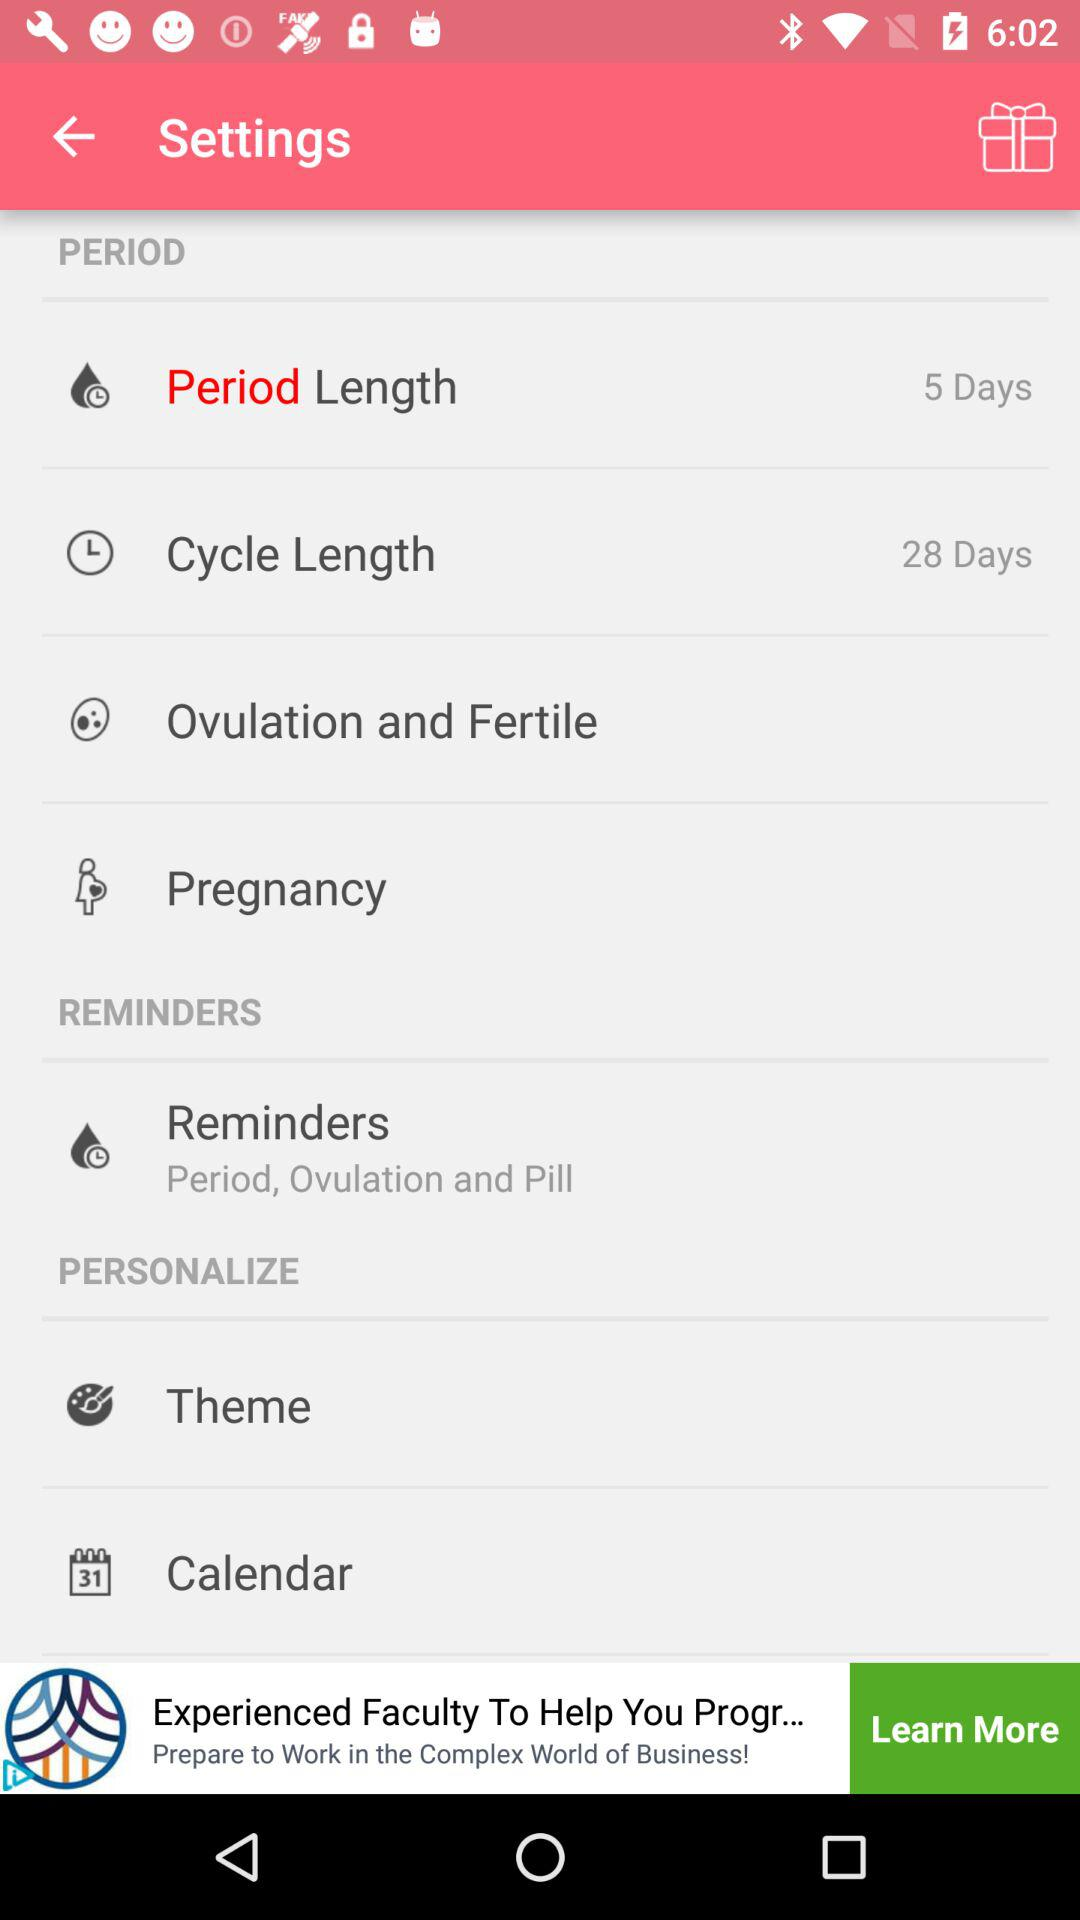What is the cycle length? The cycle length is 28 days. 